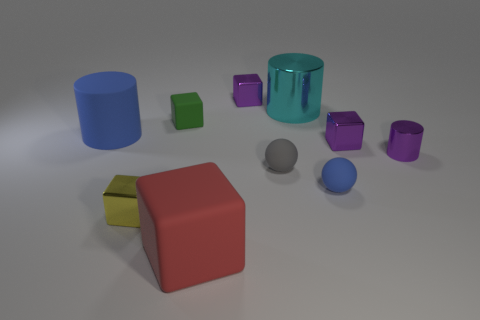Can you describe the arrangement of the objects in the image? The objects are spread out on a flat surface with no discernible pattern. There's a mixture of shapes including cylinders, cubes, and spheres with varying sizes and colors. 